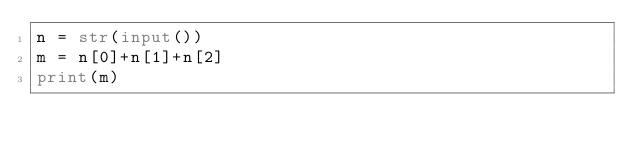<code> <loc_0><loc_0><loc_500><loc_500><_Python_>n = str(input())
m = n[0]+n[1]+n[2]
print(m)
</code> 